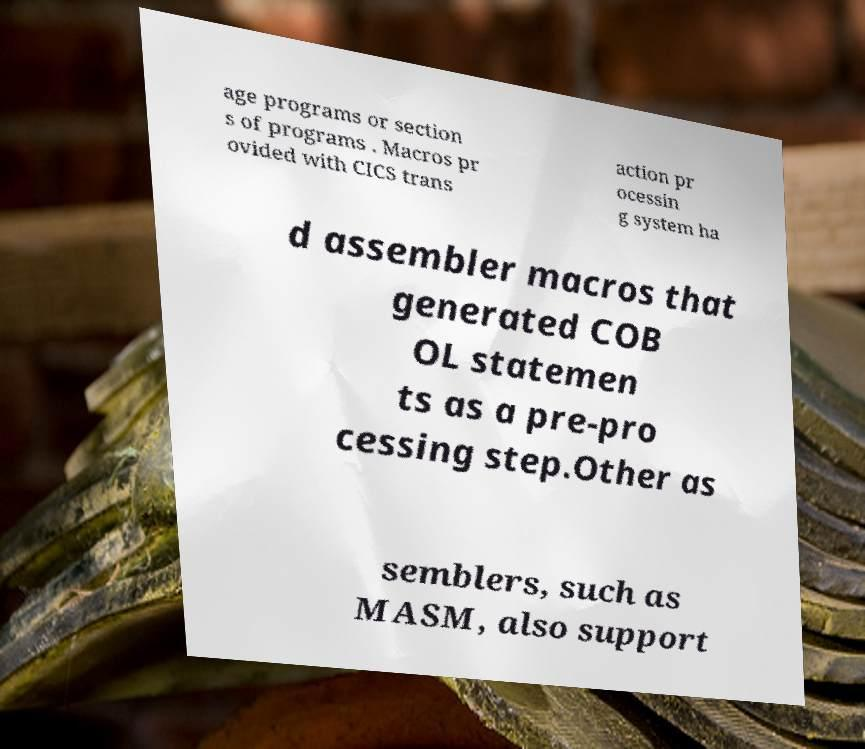Could you extract and type out the text from this image? age programs or section s of programs . Macros pr ovided with CICS trans action pr ocessin g system ha d assembler macros that generated COB OL statemen ts as a pre-pro cessing step.Other as semblers, such as MASM, also support 